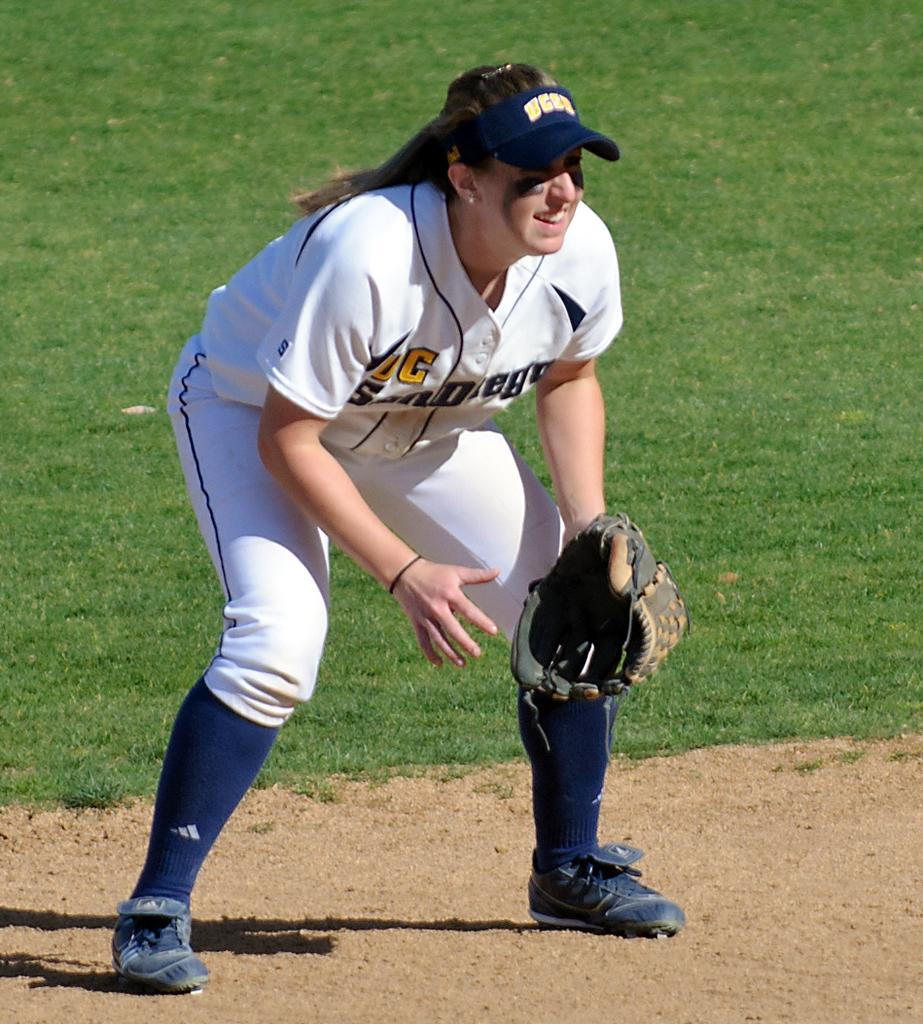<image>
Create a compact narrative representing the image presented. Girl wearing a jersey with a visor that says UCLA. 